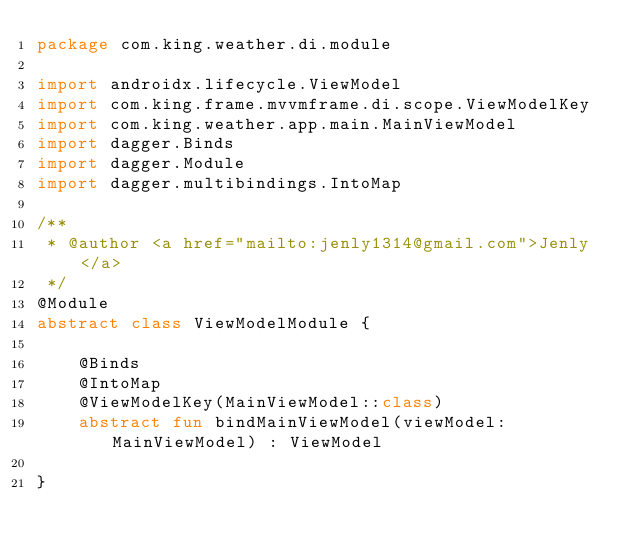Convert code to text. <code><loc_0><loc_0><loc_500><loc_500><_Kotlin_>package com.king.weather.di.module

import androidx.lifecycle.ViewModel
import com.king.frame.mvvmframe.di.scope.ViewModelKey
import com.king.weather.app.main.MainViewModel
import dagger.Binds
import dagger.Module
import dagger.multibindings.IntoMap

/**
 * @author <a href="mailto:jenly1314@gmail.com">Jenly</a>
 */
@Module
abstract class ViewModelModule {

    @Binds
    @IntoMap
    @ViewModelKey(MainViewModel::class)
    abstract fun bindMainViewModel(viewModel: MainViewModel) : ViewModel

}</code> 